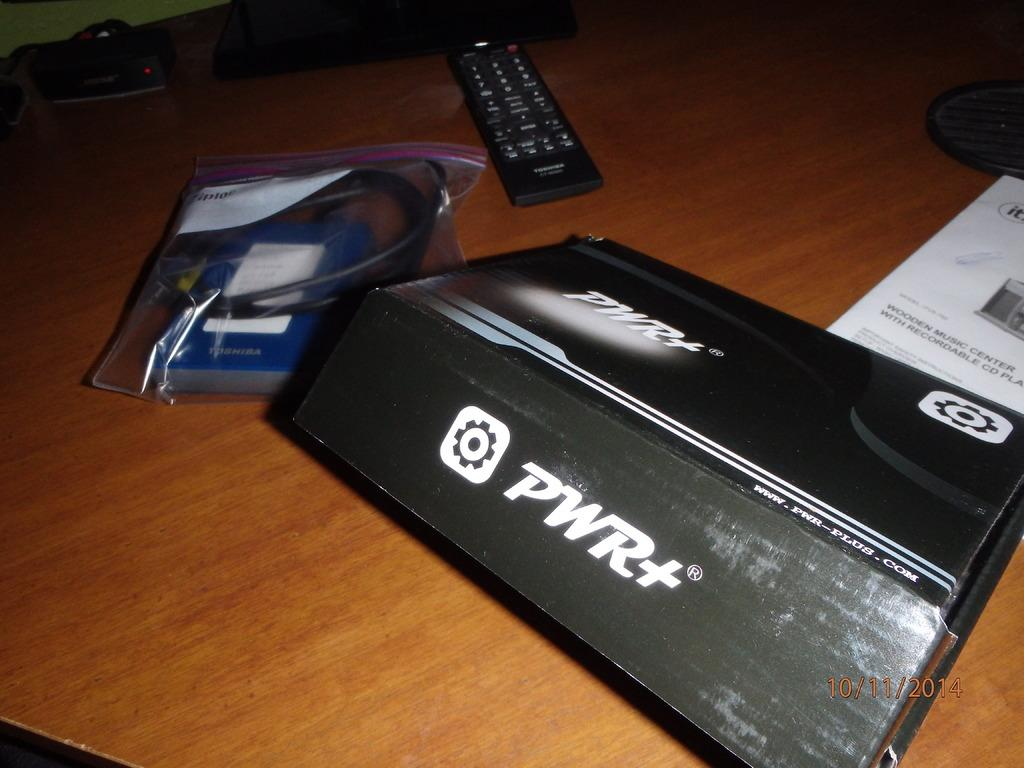<image>
Share a concise interpretation of the image provided. A black binder with the white writing reading PWR+. 